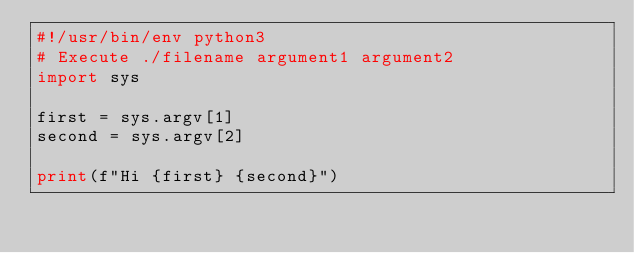Convert code to text. <code><loc_0><loc_0><loc_500><loc_500><_Python_>#!/usr/bin/env python3
# Execute ./filename argument1 argument2
import sys

first = sys.argv[1]
second = sys.argv[2]

print(f"Hi {first} {second}")</code> 